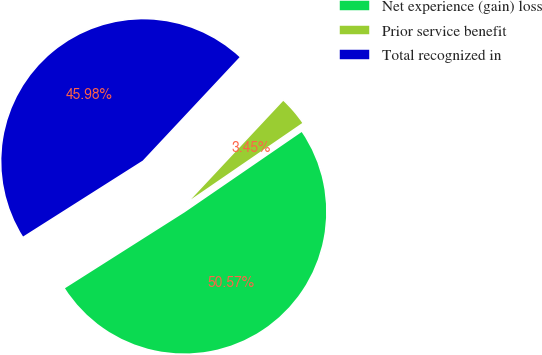Convert chart. <chart><loc_0><loc_0><loc_500><loc_500><pie_chart><fcel>Net experience (gain) loss<fcel>Prior service benefit<fcel>Total recognized in<nl><fcel>50.58%<fcel>3.45%<fcel>45.98%<nl></chart> 